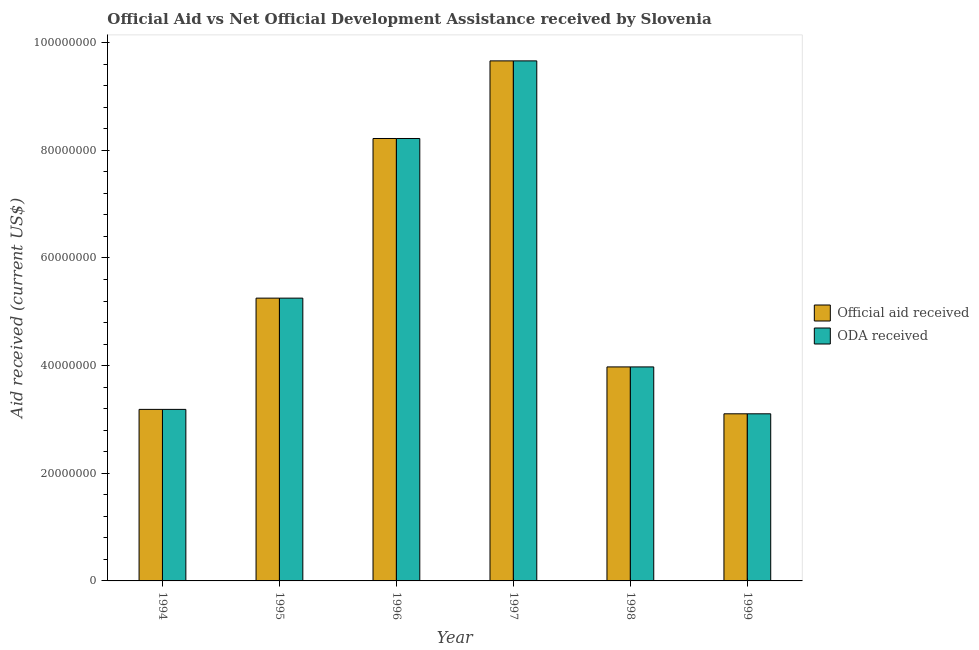How many groups of bars are there?
Your answer should be compact. 6. Are the number of bars on each tick of the X-axis equal?
Offer a very short reply. Yes. How many bars are there on the 2nd tick from the right?
Provide a short and direct response. 2. What is the official aid received in 1994?
Your response must be concise. 3.19e+07. Across all years, what is the maximum oda received?
Ensure brevity in your answer.  9.66e+07. Across all years, what is the minimum official aid received?
Offer a very short reply. 3.10e+07. In which year was the official aid received minimum?
Your answer should be compact. 1999. What is the total official aid received in the graph?
Provide a short and direct response. 3.34e+08. What is the difference between the oda received in 1994 and that in 1997?
Keep it short and to the point. -6.48e+07. What is the difference between the oda received in 1996 and the official aid received in 1994?
Provide a short and direct response. 5.03e+07. What is the average oda received per year?
Give a very brief answer. 5.57e+07. What is the ratio of the oda received in 1996 to that in 1999?
Make the answer very short. 2.65. Is the difference between the oda received in 1994 and 1998 greater than the difference between the official aid received in 1994 and 1998?
Your answer should be very brief. No. What is the difference between the highest and the second highest oda received?
Your answer should be compact. 1.44e+07. What is the difference between the highest and the lowest official aid received?
Your answer should be compact. 6.56e+07. Is the sum of the oda received in 1995 and 1999 greater than the maximum official aid received across all years?
Your answer should be compact. No. What does the 1st bar from the left in 1997 represents?
Your response must be concise. Official aid received. What does the 2nd bar from the right in 1998 represents?
Ensure brevity in your answer.  Official aid received. Are the values on the major ticks of Y-axis written in scientific E-notation?
Make the answer very short. No. Does the graph contain any zero values?
Offer a terse response. No. How are the legend labels stacked?
Provide a succinct answer. Vertical. What is the title of the graph?
Provide a short and direct response. Official Aid vs Net Official Development Assistance received by Slovenia . What is the label or title of the Y-axis?
Your answer should be compact. Aid received (current US$). What is the Aid received (current US$) of Official aid received in 1994?
Offer a terse response. 3.19e+07. What is the Aid received (current US$) in ODA received in 1994?
Make the answer very short. 3.19e+07. What is the Aid received (current US$) of Official aid received in 1995?
Give a very brief answer. 5.25e+07. What is the Aid received (current US$) of ODA received in 1995?
Offer a terse response. 5.25e+07. What is the Aid received (current US$) in Official aid received in 1996?
Ensure brevity in your answer.  8.22e+07. What is the Aid received (current US$) of ODA received in 1996?
Your response must be concise. 8.22e+07. What is the Aid received (current US$) of Official aid received in 1997?
Provide a succinct answer. 9.66e+07. What is the Aid received (current US$) of ODA received in 1997?
Offer a terse response. 9.66e+07. What is the Aid received (current US$) of Official aid received in 1998?
Keep it short and to the point. 3.98e+07. What is the Aid received (current US$) of ODA received in 1998?
Your response must be concise. 3.98e+07. What is the Aid received (current US$) in Official aid received in 1999?
Offer a very short reply. 3.10e+07. What is the Aid received (current US$) of ODA received in 1999?
Provide a succinct answer. 3.10e+07. Across all years, what is the maximum Aid received (current US$) of Official aid received?
Give a very brief answer. 9.66e+07. Across all years, what is the maximum Aid received (current US$) of ODA received?
Your answer should be compact. 9.66e+07. Across all years, what is the minimum Aid received (current US$) of Official aid received?
Your answer should be very brief. 3.10e+07. Across all years, what is the minimum Aid received (current US$) in ODA received?
Make the answer very short. 3.10e+07. What is the total Aid received (current US$) of Official aid received in the graph?
Make the answer very short. 3.34e+08. What is the total Aid received (current US$) of ODA received in the graph?
Provide a succinct answer. 3.34e+08. What is the difference between the Aid received (current US$) of Official aid received in 1994 and that in 1995?
Offer a terse response. -2.07e+07. What is the difference between the Aid received (current US$) of ODA received in 1994 and that in 1995?
Provide a succinct answer. -2.07e+07. What is the difference between the Aid received (current US$) in Official aid received in 1994 and that in 1996?
Your answer should be very brief. -5.03e+07. What is the difference between the Aid received (current US$) of ODA received in 1994 and that in 1996?
Your answer should be compact. -5.03e+07. What is the difference between the Aid received (current US$) of Official aid received in 1994 and that in 1997?
Offer a terse response. -6.48e+07. What is the difference between the Aid received (current US$) in ODA received in 1994 and that in 1997?
Ensure brevity in your answer.  -6.48e+07. What is the difference between the Aid received (current US$) in Official aid received in 1994 and that in 1998?
Offer a terse response. -7.89e+06. What is the difference between the Aid received (current US$) of ODA received in 1994 and that in 1998?
Keep it short and to the point. -7.89e+06. What is the difference between the Aid received (current US$) of Official aid received in 1994 and that in 1999?
Give a very brief answer. 8.20e+05. What is the difference between the Aid received (current US$) of ODA received in 1994 and that in 1999?
Make the answer very short. 8.20e+05. What is the difference between the Aid received (current US$) in Official aid received in 1995 and that in 1996?
Offer a very short reply. -2.97e+07. What is the difference between the Aid received (current US$) in ODA received in 1995 and that in 1996?
Make the answer very short. -2.97e+07. What is the difference between the Aid received (current US$) of Official aid received in 1995 and that in 1997?
Your answer should be compact. -4.41e+07. What is the difference between the Aid received (current US$) in ODA received in 1995 and that in 1997?
Provide a succinct answer. -4.41e+07. What is the difference between the Aid received (current US$) in Official aid received in 1995 and that in 1998?
Your answer should be compact. 1.28e+07. What is the difference between the Aid received (current US$) in ODA received in 1995 and that in 1998?
Offer a very short reply. 1.28e+07. What is the difference between the Aid received (current US$) in Official aid received in 1995 and that in 1999?
Offer a very short reply. 2.15e+07. What is the difference between the Aid received (current US$) of ODA received in 1995 and that in 1999?
Provide a short and direct response. 2.15e+07. What is the difference between the Aid received (current US$) in Official aid received in 1996 and that in 1997?
Offer a terse response. -1.44e+07. What is the difference between the Aid received (current US$) of ODA received in 1996 and that in 1997?
Ensure brevity in your answer.  -1.44e+07. What is the difference between the Aid received (current US$) in Official aid received in 1996 and that in 1998?
Offer a very short reply. 4.24e+07. What is the difference between the Aid received (current US$) in ODA received in 1996 and that in 1998?
Offer a terse response. 4.24e+07. What is the difference between the Aid received (current US$) of Official aid received in 1996 and that in 1999?
Keep it short and to the point. 5.12e+07. What is the difference between the Aid received (current US$) in ODA received in 1996 and that in 1999?
Ensure brevity in your answer.  5.12e+07. What is the difference between the Aid received (current US$) in Official aid received in 1997 and that in 1998?
Your response must be concise. 5.69e+07. What is the difference between the Aid received (current US$) in ODA received in 1997 and that in 1998?
Provide a short and direct response. 5.69e+07. What is the difference between the Aid received (current US$) of Official aid received in 1997 and that in 1999?
Offer a very short reply. 6.56e+07. What is the difference between the Aid received (current US$) of ODA received in 1997 and that in 1999?
Offer a very short reply. 6.56e+07. What is the difference between the Aid received (current US$) in Official aid received in 1998 and that in 1999?
Your answer should be compact. 8.71e+06. What is the difference between the Aid received (current US$) in ODA received in 1998 and that in 1999?
Offer a very short reply. 8.71e+06. What is the difference between the Aid received (current US$) in Official aid received in 1994 and the Aid received (current US$) in ODA received in 1995?
Your answer should be very brief. -2.07e+07. What is the difference between the Aid received (current US$) in Official aid received in 1994 and the Aid received (current US$) in ODA received in 1996?
Your answer should be compact. -5.03e+07. What is the difference between the Aid received (current US$) in Official aid received in 1994 and the Aid received (current US$) in ODA received in 1997?
Your answer should be very brief. -6.48e+07. What is the difference between the Aid received (current US$) in Official aid received in 1994 and the Aid received (current US$) in ODA received in 1998?
Offer a terse response. -7.89e+06. What is the difference between the Aid received (current US$) in Official aid received in 1994 and the Aid received (current US$) in ODA received in 1999?
Give a very brief answer. 8.20e+05. What is the difference between the Aid received (current US$) of Official aid received in 1995 and the Aid received (current US$) of ODA received in 1996?
Provide a succinct answer. -2.97e+07. What is the difference between the Aid received (current US$) of Official aid received in 1995 and the Aid received (current US$) of ODA received in 1997?
Ensure brevity in your answer.  -4.41e+07. What is the difference between the Aid received (current US$) in Official aid received in 1995 and the Aid received (current US$) in ODA received in 1998?
Your answer should be very brief. 1.28e+07. What is the difference between the Aid received (current US$) in Official aid received in 1995 and the Aid received (current US$) in ODA received in 1999?
Your answer should be very brief. 2.15e+07. What is the difference between the Aid received (current US$) of Official aid received in 1996 and the Aid received (current US$) of ODA received in 1997?
Your answer should be very brief. -1.44e+07. What is the difference between the Aid received (current US$) of Official aid received in 1996 and the Aid received (current US$) of ODA received in 1998?
Provide a short and direct response. 4.24e+07. What is the difference between the Aid received (current US$) of Official aid received in 1996 and the Aid received (current US$) of ODA received in 1999?
Offer a very short reply. 5.12e+07. What is the difference between the Aid received (current US$) in Official aid received in 1997 and the Aid received (current US$) in ODA received in 1998?
Make the answer very short. 5.69e+07. What is the difference between the Aid received (current US$) in Official aid received in 1997 and the Aid received (current US$) in ODA received in 1999?
Offer a very short reply. 6.56e+07. What is the difference between the Aid received (current US$) in Official aid received in 1998 and the Aid received (current US$) in ODA received in 1999?
Make the answer very short. 8.71e+06. What is the average Aid received (current US$) in Official aid received per year?
Your answer should be compact. 5.57e+07. What is the average Aid received (current US$) in ODA received per year?
Your answer should be very brief. 5.57e+07. In the year 1995, what is the difference between the Aid received (current US$) of Official aid received and Aid received (current US$) of ODA received?
Offer a very short reply. 0. In the year 1997, what is the difference between the Aid received (current US$) in Official aid received and Aid received (current US$) in ODA received?
Keep it short and to the point. 0. In the year 1998, what is the difference between the Aid received (current US$) of Official aid received and Aid received (current US$) of ODA received?
Ensure brevity in your answer.  0. In the year 1999, what is the difference between the Aid received (current US$) of Official aid received and Aid received (current US$) of ODA received?
Make the answer very short. 0. What is the ratio of the Aid received (current US$) of Official aid received in 1994 to that in 1995?
Make the answer very short. 0.61. What is the ratio of the Aid received (current US$) in ODA received in 1994 to that in 1995?
Keep it short and to the point. 0.61. What is the ratio of the Aid received (current US$) of Official aid received in 1994 to that in 1996?
Provide a succinct answer. 0.39. What is the ratio of the Aid received (current US$) of ODA received in 1994 to that in 1996?
Offer a terse response. 0.39. What is the ratio of the Aid received (current US$) in Official aid received in 1994 to that in 1997?
Offer a terse response. 0.33. What is the ratio of the Aid received (current US$) of ODA received in 1994 to that in 1997?
Your answer should be very brief. 0.33. What is the ratio of the Aid received (current US$) of Official aid received in 1994 to that in 1998?
Your response must be concise. 0.8. What is the ratio of the Aid received (current US$) in ODA received in 1994 to that in 1998?
Keep it short and to the point. 0.8. What is the ratio of the Aid received (current US$) of Official aid received in 1994 to that in 1999?
Offer a very short reply. 1.03. What is the ratio of the Aid received (current US$) in ODA received in 1994 to that in 1999?
Keep it short and to the point. 1.03. What is the ratio of the Aid received (current US$) in Official aid received in 1995 to that in 1996?
Make the answer very short. 0.64. What is the ratio of the Aid received (current US$) in ODA received in 1995 to that in 1996?
Keep it short and to the point. 0.64. What is the ratio of the Aid received (current US$) in Official aid received in 1995 to that in 1997?
Ensure brevity in your answer.  0.54. What is the ratio of the Aid received (current US$) of ODA received in 1995 to that in 1997?
Your answer should be compact. 0.54. What is the ratio of the Aid received (current US$) of Official aid received in 1995 to that in 1998?
Offer a terse response. 1.32. What is the ratio of the Aid received (current US$) in ODA received in 1995 to that in 1998?
Keep it short and to the point. 1.32. What is the ratio of the Aid received (current US$) of Official aid received in 1995 to that in 1999?
Your answer should be very brief. 1.69. What is the ratio of the Aid received (current US$) of ODA received in 1995 to that in 1999?
Make the answer very short. 1.69. What is the ratio of the Aid received (current US$) of Official aid received in 1996 to that in 1997?
Provide a short and direct response. 0.85. What is the ratio of the Aid received (current US$) in ODA received in 1996 to that in 1997?
Offer a very short reply. 0.85. What is the ratio of the Aid received (current US$) of Official aid received in 1996 to that in 1998?
Make the answer very short. 2.07. What is the ratio of the Aid received (current US$) of ODA received in 1996 to that in 1998?
Your response must be concise. 2.07. What is the ratio of the Aid received (current US$) in Official aid received in 1996 to that in 1999?
Offer a very short reply. 2.65. What is the ratio of the Aid received (current US$) of ODA received in 1996 to that in 1999?
Give a very brief answer. 2.65. What is the ratio of the Aid received (current US$) in Official aid received in 1997 to that in 1998?
Keep it short and to the point. 2.43. What is the ratio of the Aid received (current US$) of ODA received in 1997 to that in 1998?
Ensure brevity in your answer.  2.43. What is the ratio of the Aid received (current US$) of Official aid received in 1997 to that in 1999?
Offer a very short reply. 3.11. What is the ratio of the Aid received (current US$) of ODA received in 1997 to that in 1999?
Your answer should be compact. 3.11. What is the ratio of the Aid received (current US$) in Official aid received in 1998 to that in 1999?
Ensure brevity in your answer.  1.28. What is the ratio of the Aid received (current US$) of ODA received in 1998 to that in 1999?
Keep it short and to the point. 1.28. What is the difference between the highest and the second highest Aid received (current US$) of Official aid received?
Ensure brevity in your answer.  1.44e+07. What is the difference between the highest and the second highest Aid received (current US$) in ODA received?
Offer a very short reply. 1.44e+07. What is the difference between the highest and the lowest Aid received (current US$) in Official aid received?
Offer a very short reply. 6.56e+07. What is the difference between the highest and the lowest Aid received (current US$) of ODA received?
Your answer should be compact. 6.56e+07. 